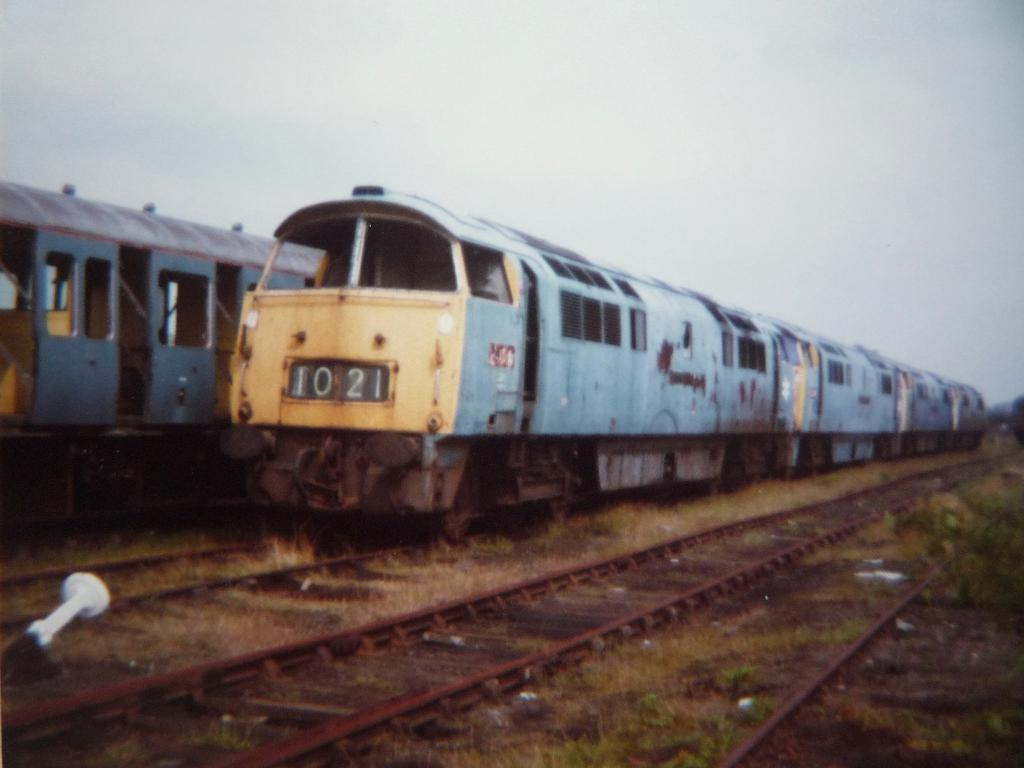How many trains can be seen in the image? There are two trains in the image. Where are the trains located? The trains are on train tracks. How many train tracks are visible in the image? There are multiple train tracks in the image. What is growing between the train tracks? Grass is present between the train tracks. What is the color of the sky in the image? The sky is pale blue in the image. What type of chalk is being used to draw on the train tracks in the image? There is no chalk or drawing activity present in the image. How much credit is given to the train conductor in the image? There is no mention of credit or a train conductor in the image. 